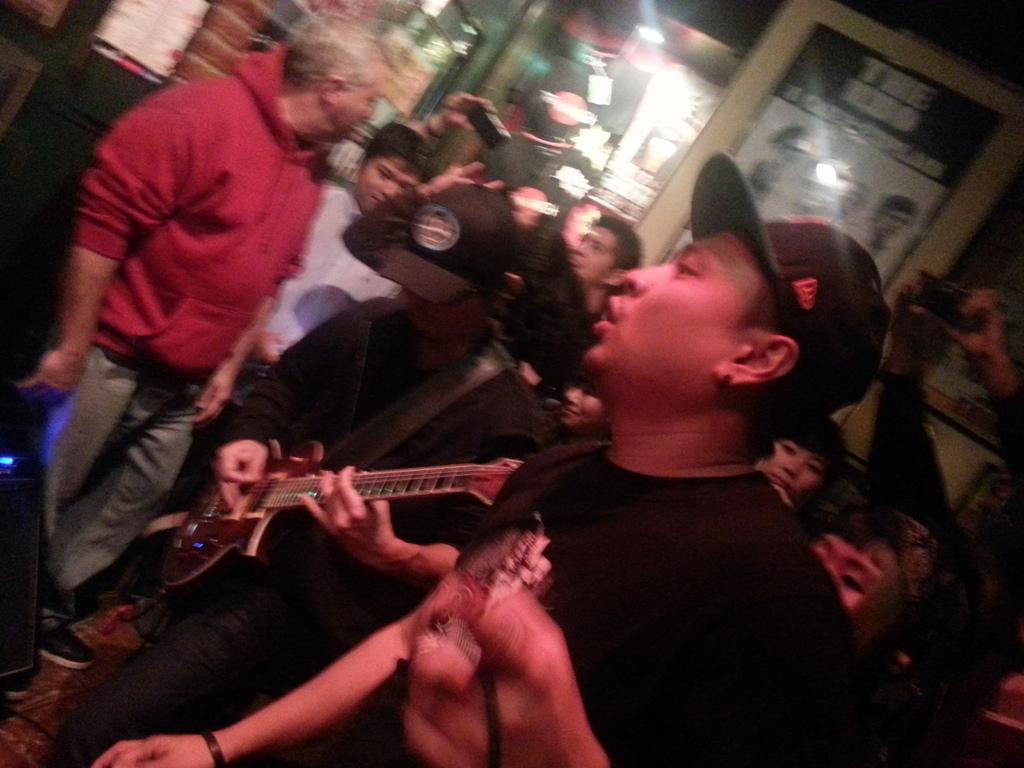In one or two sentences, can you explain what this image depicts? This is a picture taken in a restaurant, there are so many people in the crowd and the man in black t shirt wearing a black hat were singing a song and the other men in black t shirt were playing the guitar. And the other people were recording the performance of this people. 